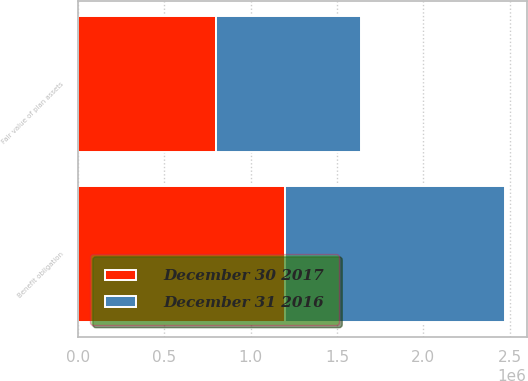Convert chart to OTSL. <chart><loc_0><loc_0><loc_500><loc_500><stacked_bar_chart><ecel><fcel>Benefit obligation<fcel>Fair value of plan assets<nl><fcel>December 31 2016<fcel>1.27772e+06<fcel>842168<nl><fcel>December 30 2017<fcel>1.19719e+06<fcel>799191<nl></chart> 